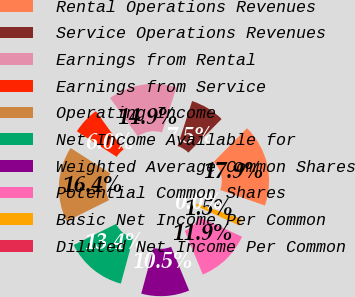Convert chart to OTSL. <chart><loc_0><loc_0><loc_500><loc_500><pie_chart><fcel>Rental Operations Revenues<fcel>Service Operations Revenues<fcel>Earnings from Rental<fcel>Earnings from Service<fcel>Operating Income<fcel>Net Income Available for<fcel>Weighted Average Common Shares<fcel>Potential Common Shares<fcel>Basic Net Income Per Common<fcel>Diluted Net Income Per Common<nl><fcel>17.91%<fcel>7.46%<fcel>14.93%<fcel>5.97%<fcel>16.42%<fcel>13.43%<fcel>10.45%<fcel>11.94%<fcel>1.49%<fcel>0.0%<nl></chart> 